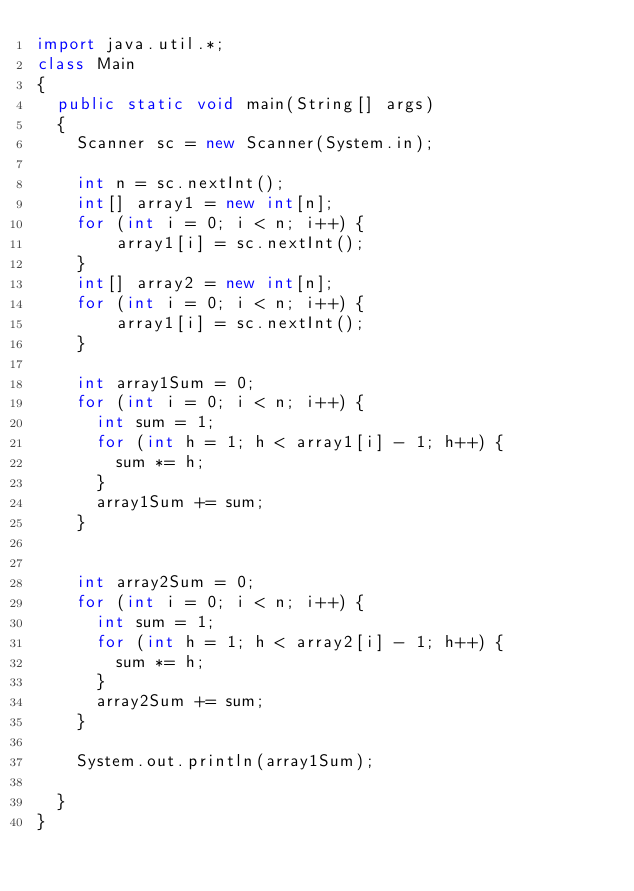Convert code to text. <code><loc_0><loc_0><loc_500><loc_500><_Java_>import java.util.*;
class Main
{
  public static void main(String[] args)
  {
    Scanner sc = new Scanner(System.in);
    
    int n = sc.nextInt();
    int[] array1 = new int[n];
    for (int i = 0; i < n; i++) {
        array1[i] = sc.nextInt();
    }
    int[] array2 = new int[n];
    for (int i = 0; i < n; i++) {
        array1[i] = sc.nextInt();
    }
     
    int array1Sum = 0;
    for (int i = 0; i < n; i++) {
      int sum = 1;
      for (int h = 1; h < array1[i] - 1; h++) {
        sum *= h;
      }
      array1Sum += sum;
    }
    
    
    int array2Sum = 0;
    for (int i = 0; i < n; i++) {
      int sum = 1;
      for (int h = 1; h < array2[i] - 1; h++) {
        sum *= h;
      }
      array2Sum += sum;
    }
    
    System.out.println(array1Sum);
    
  }
}</code> 